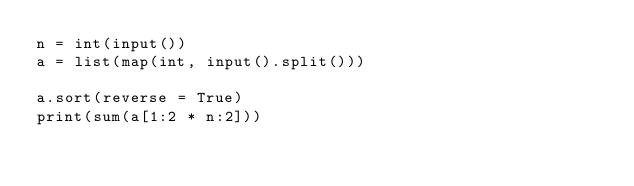Convert code to text. <code><loc_0><loc_0><loc_500><loc_500><_Python_>n = int(input())
a = list(map(int, input().split()))

a.sort(reverse = True)
print(sum(a[1:2 * n:2]))</code> 